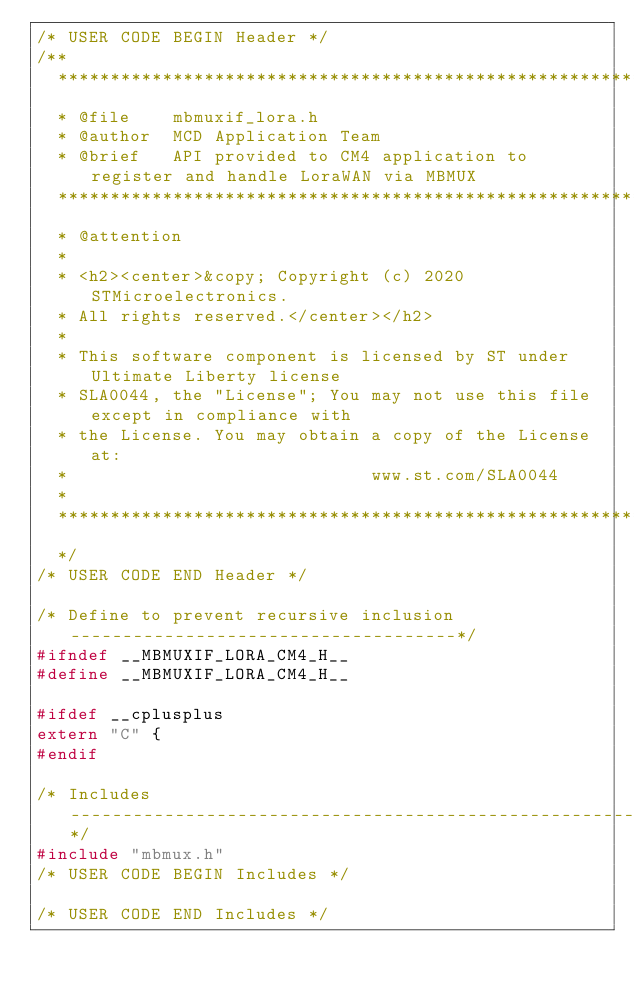<code> <loc_0><loc_0><loc_500><loc_500><_C_>/* USER CODE BEGIN Header */
/**
  ******************************************************************************
  * @file    mbmuxif_lora.h
  * @author  MCD Application Team
  * @brief   API provided to CM4 application to register and handle LoraWAN via MBMUX
  ******************************************************************************
  * @attention
  *
  * <h2><center>&copy; Copyright (c) 2020 STMicroelectronics.
  * All rights reserved.</center></h2>
  *
  * This software component is licensed by ST under Ultimate Liberty license
  * SLA0044, the "License"; You may not use this file except in compliance with
  * the License. You may obtain a copy of the License at:
  *                             www.st.com/SLA0044
  *
  ******************************************************************************
  */
/* USER CODE END Header */

/* Define to prevent recursive inclusion -------------------------------------*/
#ifndef __MBMUXIF_LORA_CM4_H__
#define __MBMUXIF_LORA_CM4_H__

#ifdef __cplusplus
extern "C" {
#endif

/* Includes ------------------------------------------------------------------*/
#include "mbmux.h"
/* USER CODE BEGIN Includes */

/* USER CODE END Includes */
</code> 